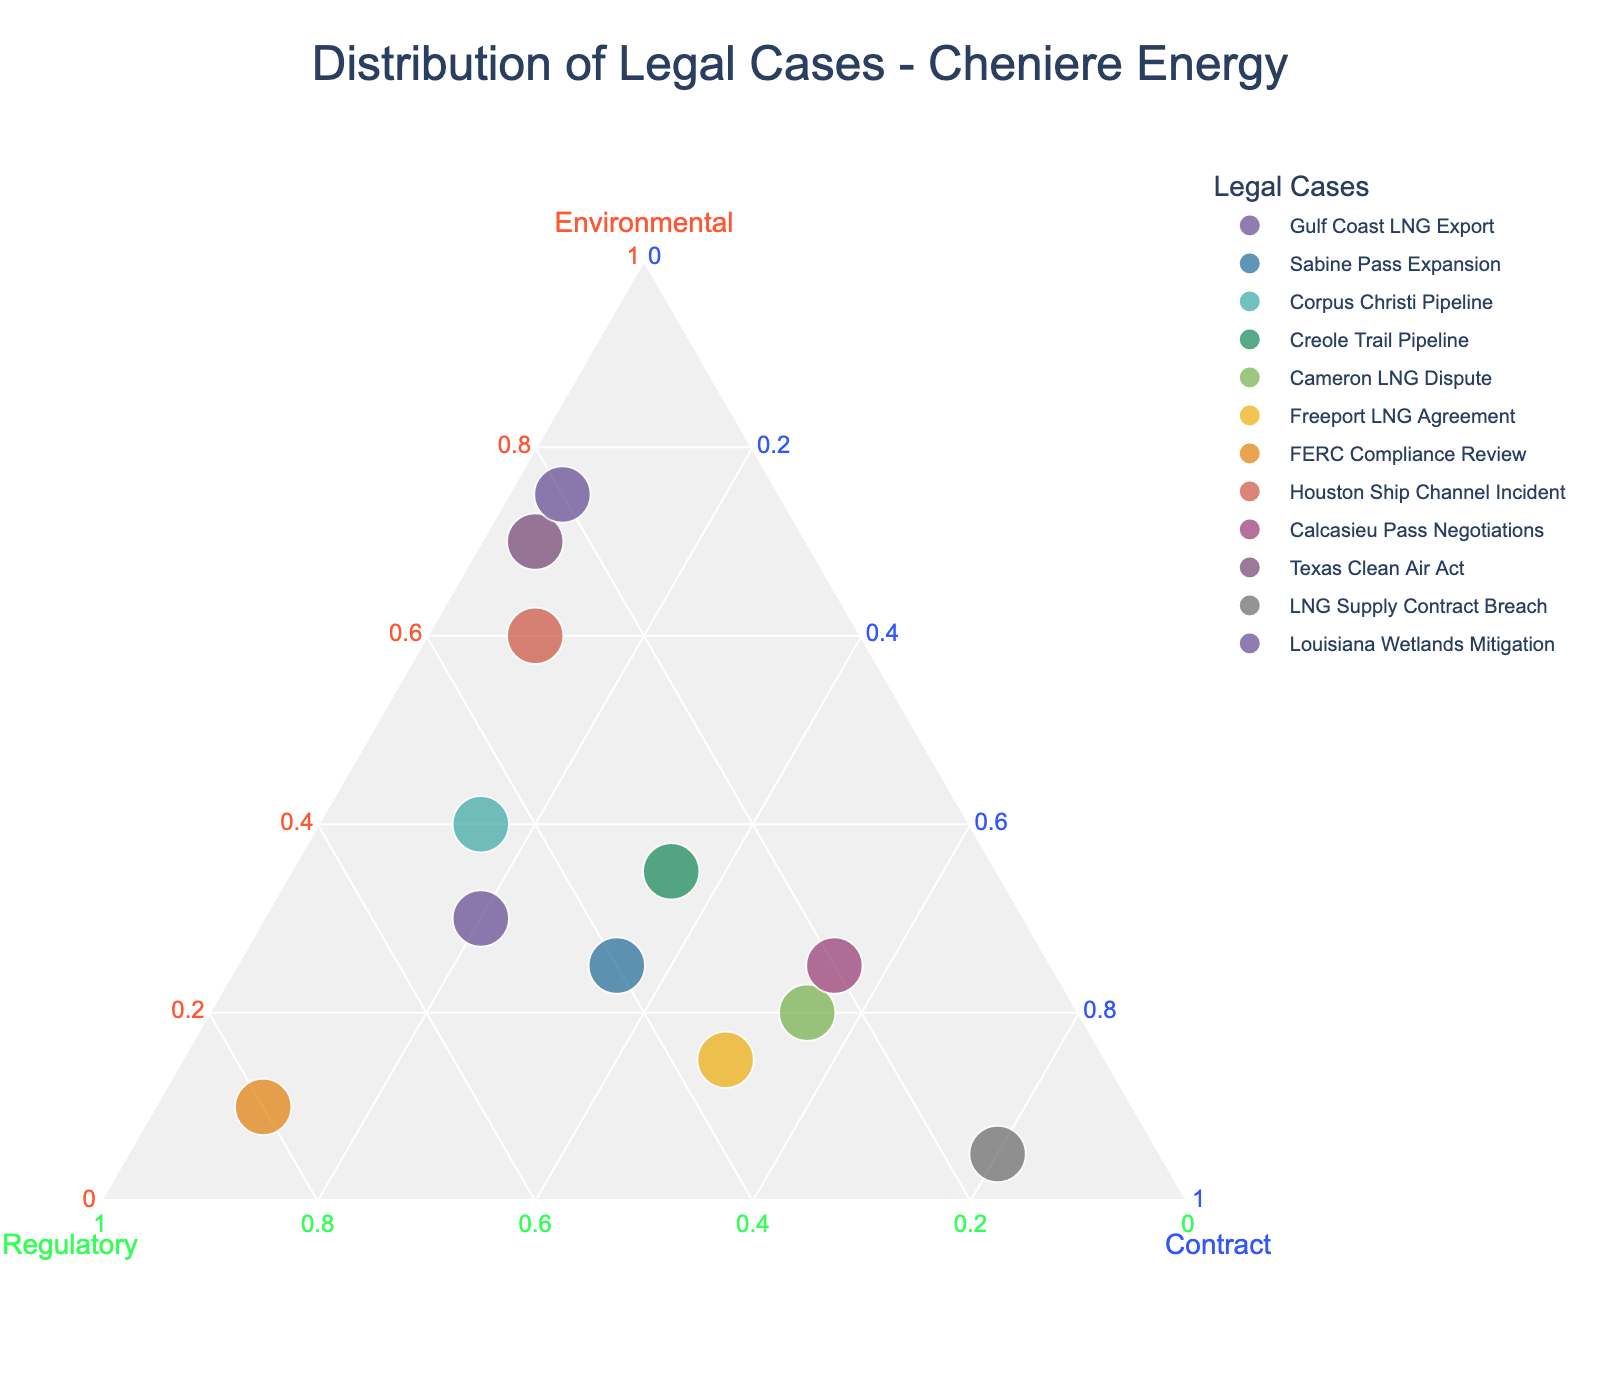What's the title of the figure? The title is usually displayed prominently at the top of the figure.
Answer: Distribution of Legal Cases - Cheniere Energy How many data points are represented in the figure? Each data point corresponds to a case in the dataset. By counting each case listed, we determine there are 12 data points.
Answer: 12 Which case has the highest proportion of contract disputes? By examining the points near the "Contract" axis, the one closest to this axis represents the highest proportion.
Answer: LNG Supply Contract Breach Which case has the highest proportion of regulatory issues? Points closest to the "Regulatory" axis indicate a higher proportion of regulatory issues. The point nearest to this axis is our answer.
Answer: FERC Compliance Review Which case is composed of exactly 70% environmental issues? By checking the data points near the "Environmental" axis, we find the one at 70%.
Answer: Texas Clean Air Act What is the relationship between 'Cameron LNG Dispute' and 'Freeport LNG Agreement' in terms of contract disputes? Both cases are positioned close to the "Contract" axis, but we need to identify which one is marginally closer or if they are equally close.
Answer: Cameron LNG Dispute has a slightly higher proportion How do the environmental proportions of 'Louisiana Wetlands Mitigation' and 'Houston Ship Channel Incident' compare? By examining the distance of these points from the "Environmental" axis, we can compare their positions.
Answer: Louisiana Wetlands Mitigation has a higher environmental proportion than Houston Ship Channel Incident What's the combined proportion of regulatory and contract disputes for 'Sabine Pass Expansion'? Adding the regulatory (40%) and contract (35%) components together.
Answer: 75% Which cases have an environmental proportion of at least 50%? Points near or past the midpoint (0.5 or 50%) on the "Environmental" axis include these cases.
Answer: Texas Clean Air Act, Louisiana Wetlands Mitigation, Houston Ship Channel Incident 